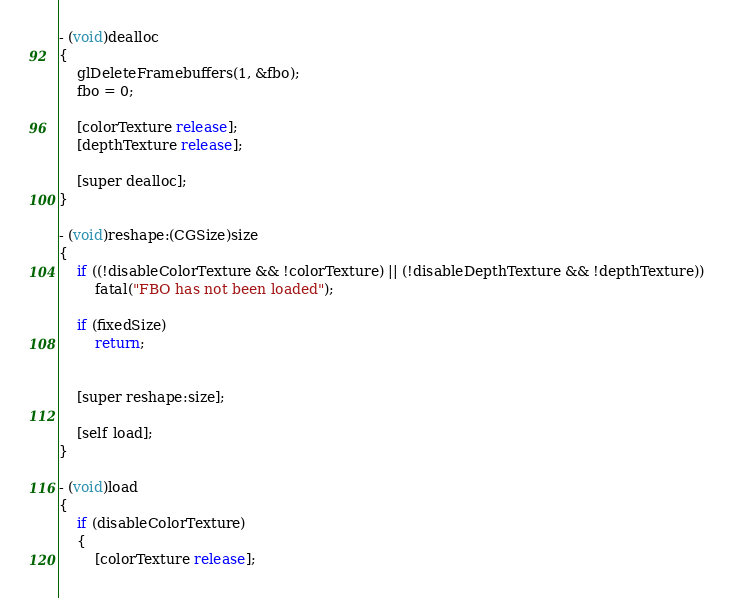Convert code to text. <code><loc_0><loc_0><loc_500><loc_500><_ObjectiveC_>
- (void)dealloc
{
	glDeleteFramebuffers(1, &fbo);
	fbo = 0;

	[colorTexture release];
	[depthTexture release];

	[super dealloc];
}

- (void)reshape:(CGSize)size
{
	if ((!disableColorTexture && !colorTexture) || (!disableDepthTexture && !depthTexture))
		fatal("FBO has not been loaded");

	if (fixedSize)
		return;


	[super reshape:size];

	[self load];
}

- (void)load
{
	if (disableColorTexture)
	{
		[colorTexture release];</code> 